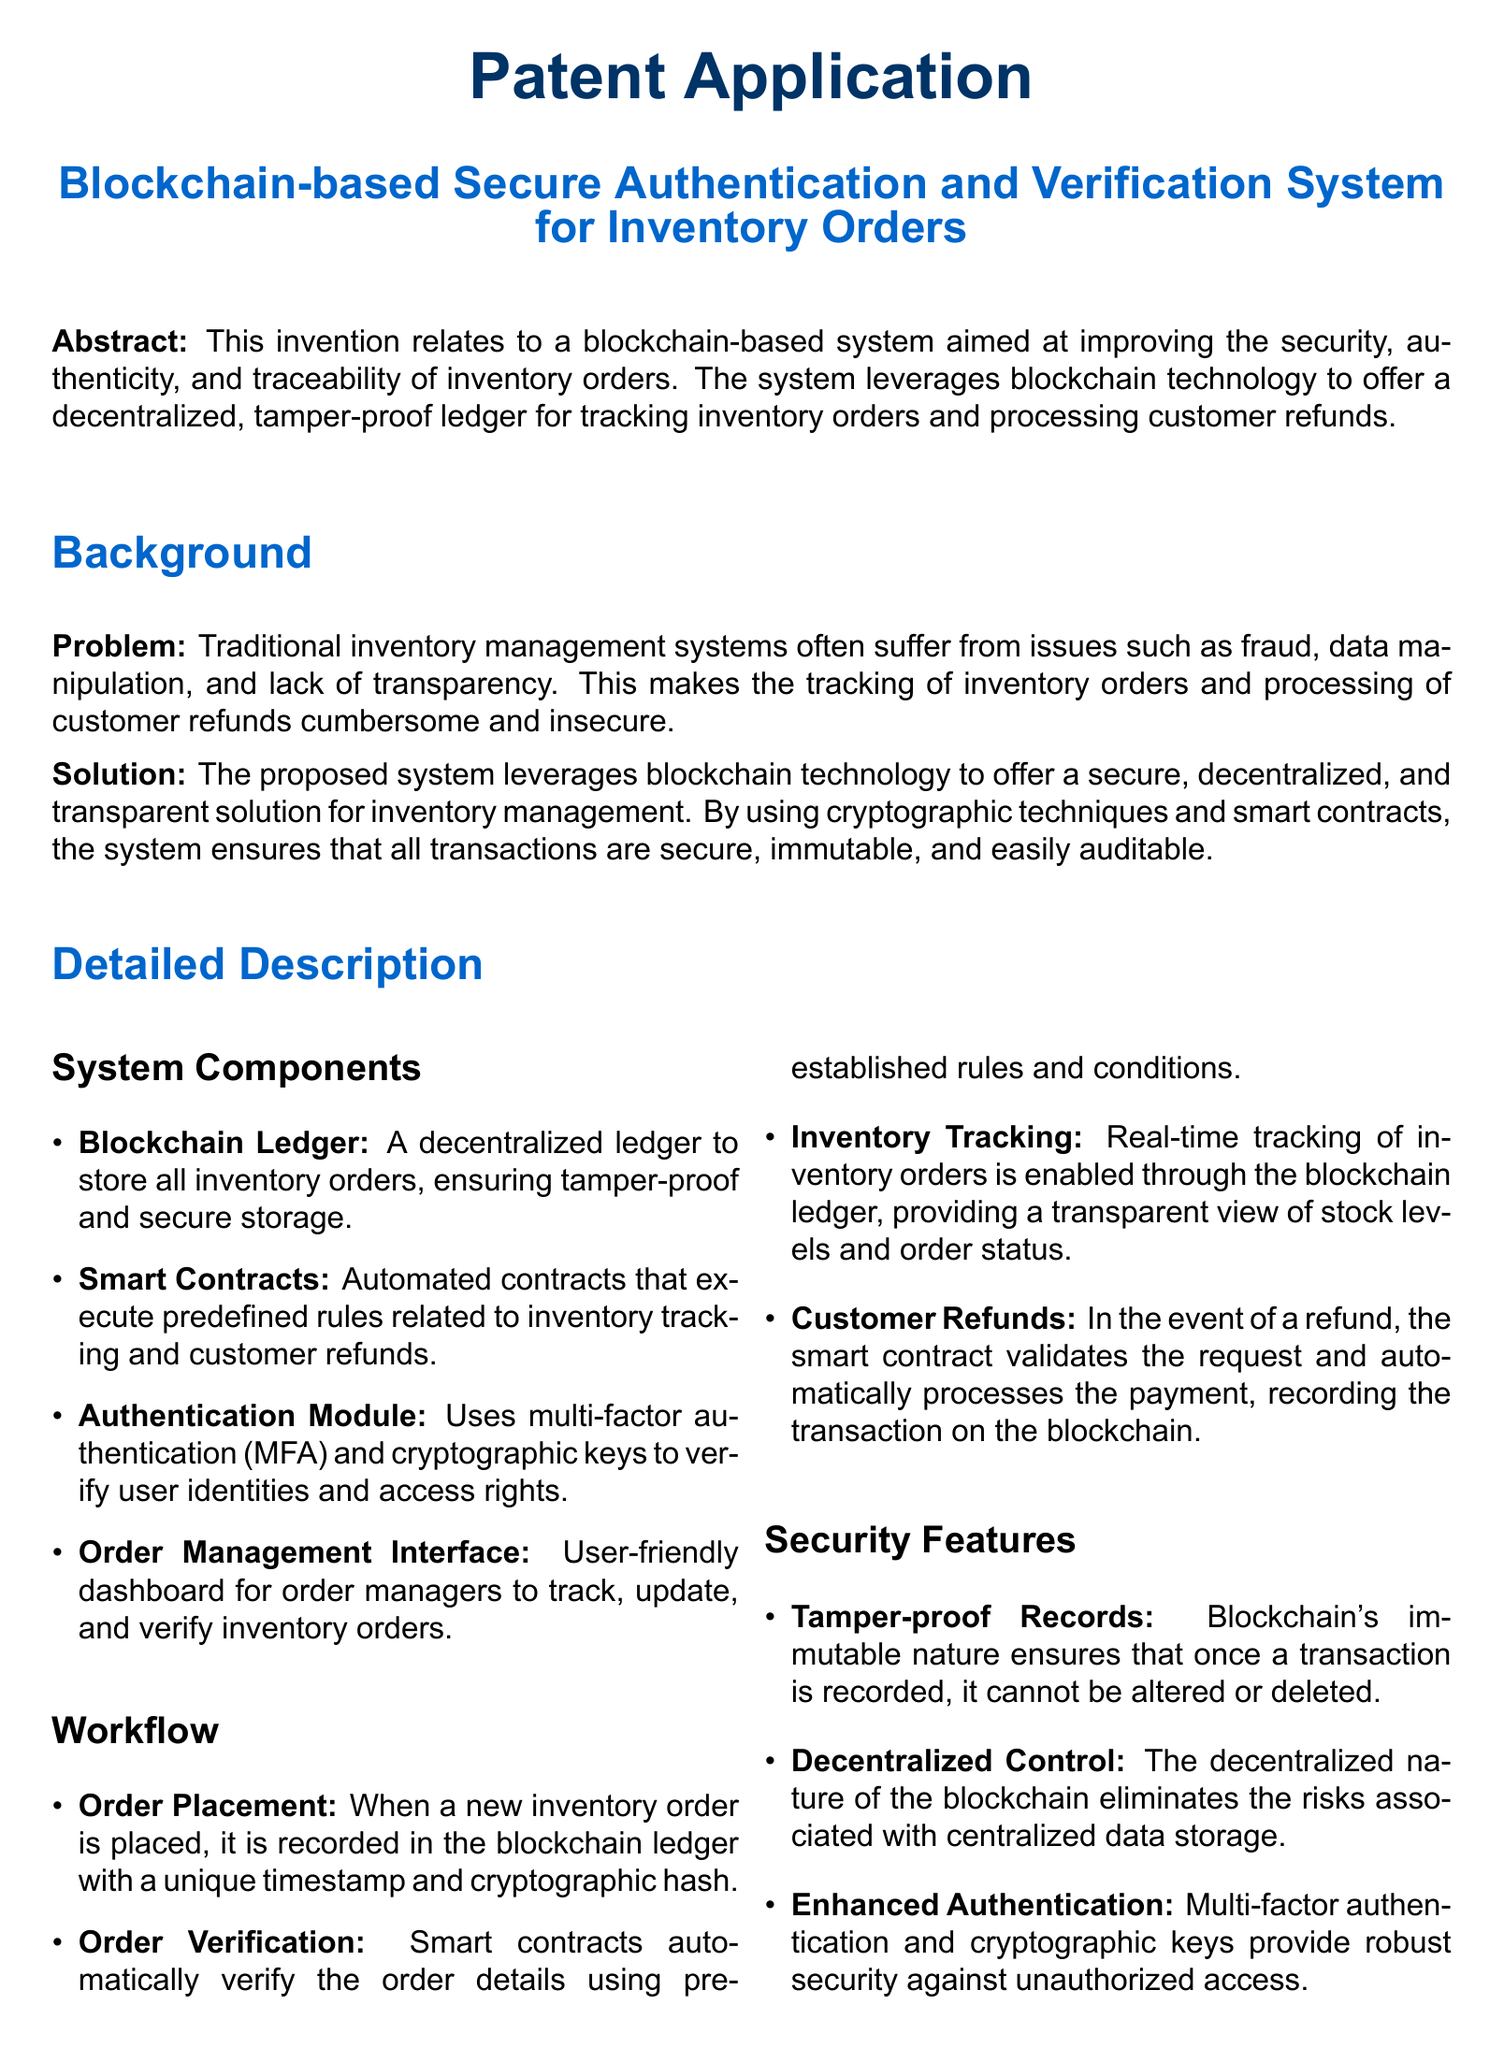What is the title of the patent application? The title is explicitly stated in the header of the document.
Answer: Blockchain-based Secure Authentication and Verification System for Inventory Orders What technology does the proposed system leverage? The technology used is mentioned in the background section addressing the solution.
Answer: Blockchain technology What is the purpose of the smart contracts in the system? The purpose of smart contracts is explained in the detailed description section.
Answer: Automatically execute order verification and customer refund processes What module is used for verifying user identities? The document specifies the component responsible for authentication.
Answer: Authentication Module How many claims are presented in the document? The number of claims is listed at the beginning of the claims section.
Answer: Five What feature ensures that transaction records cannot be altered? This feature is specified in the security features section of the document.
Answer: Tamper-proof Records What happens during order placement? This process is detailed in the workflow section, capturing the essence of recording orders.
Answer: Recorded in the blockchain ledger Which authentication method is utilized by the system? The specific method is mentioned in the authentication module description.
Answer: Multi-factor authentication What does the user interface allow order managers to do? The document outlines the capabilities provided by the user interface.
Answer: Track, update, and verify inventory orders in real-time 